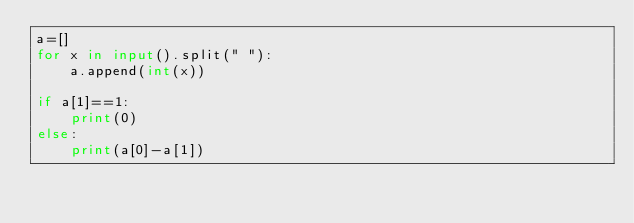<code> <loc_0><loc_0><loc_500><loc_500><_Python_>a=[]
for x in input().split(" "):
    a.append(int(x))

if a[1]==1:
    print(0)
else:
    print(a[0]-a[1])</code> 